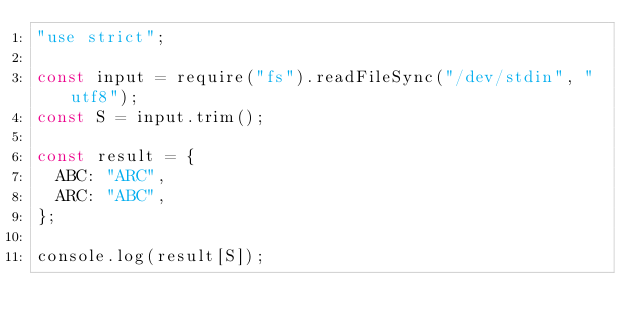<code> <loc_0><loc_0><loc_500><loc_500><_JavaScript_>"use strict";

const input = require("fs").readFileSync("/dev/stdin", "utf8");
const S = input.trim();

const result = {
  ABC: "ARC",
  ARC: "ABC",
};

console.log(result[S]);
</code> 